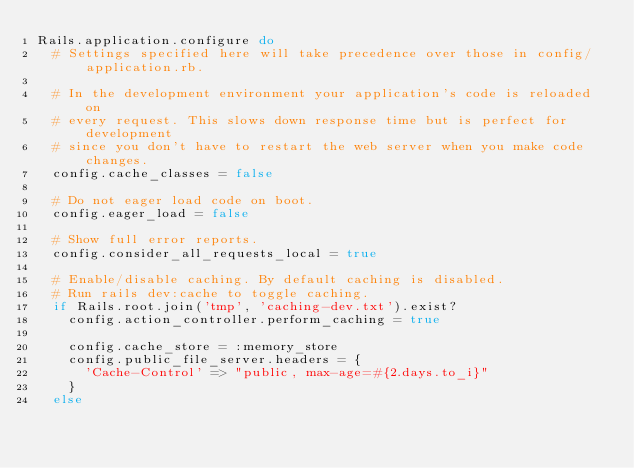Convert code to text. <code><loc_0><loc_0><loc_500><loc_500><_Ruby_>Rails.application.configure do
  # Settings specified here will take precedence over those in config/application.rb.

  # In the development environment your application's code is reloaded on
  # every request. This slows down response time but is perfect for development
  # since you don't have to restart the web server when you make code changes.
  config.cache_classes = false

  # Do not eager load code on boot.
  config.eager_load = false

  # Show full error reports.
  config.consider_all_requests_local = true

  # Enable/disable caching. By default caching is disabled.
  # Run rails dev:cache to toggle caching.
  if Rails.root.join('tmp', 'caching-dev.txt').exist?
    config.action_controller.perform_caching = true

    config.cache_store = :memory_store
    config.public_file_server.headers = {
      'Cache-Control' => "public, max-age=#{2.days.to_i}"
    }
  else</code> 